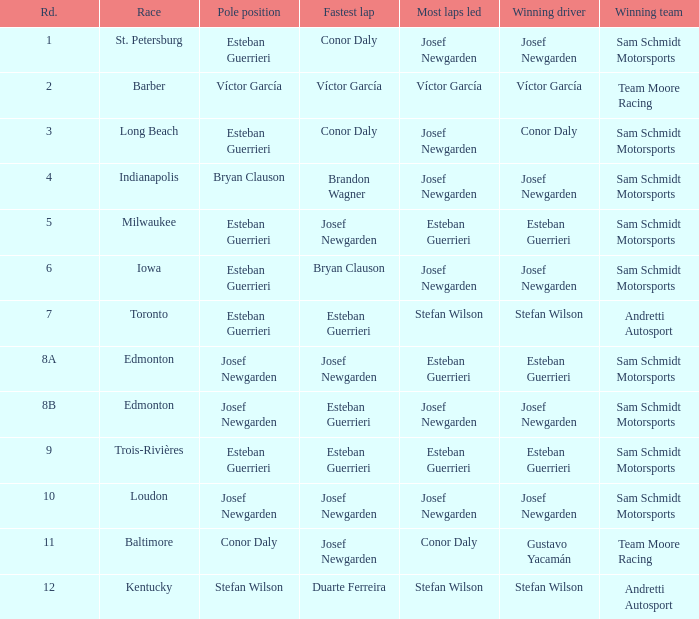Who had the fastest lap(s) when josef newgarden led the most laps at edmonton? Esteban Guerrieri. 